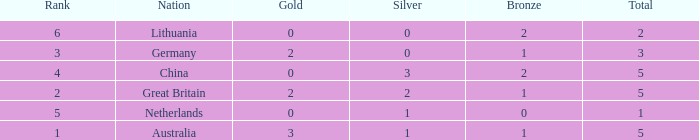What is the average Rank when there are 2 bronze, the total is 2 and gold is less than 0? None. 